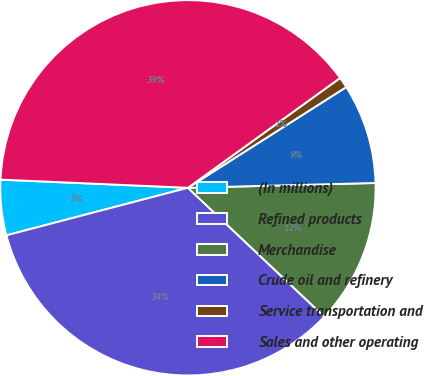Convert chart to OTSL. <chart><loc_0><loc_0><loc_500><loc_500><pie_chart><fcel>(In millions)<fcel>Refined products<fcel>Merchandise<fcel>Crude oil and refinery<fcel>Service transportation and<fcel>Sales and other operating<nl><fcel>4.77%<fcel>33.87%<fcel>12.46%<fcel>8.61%<fcel>0.93%<fcel>39.36%<nl></chart> 